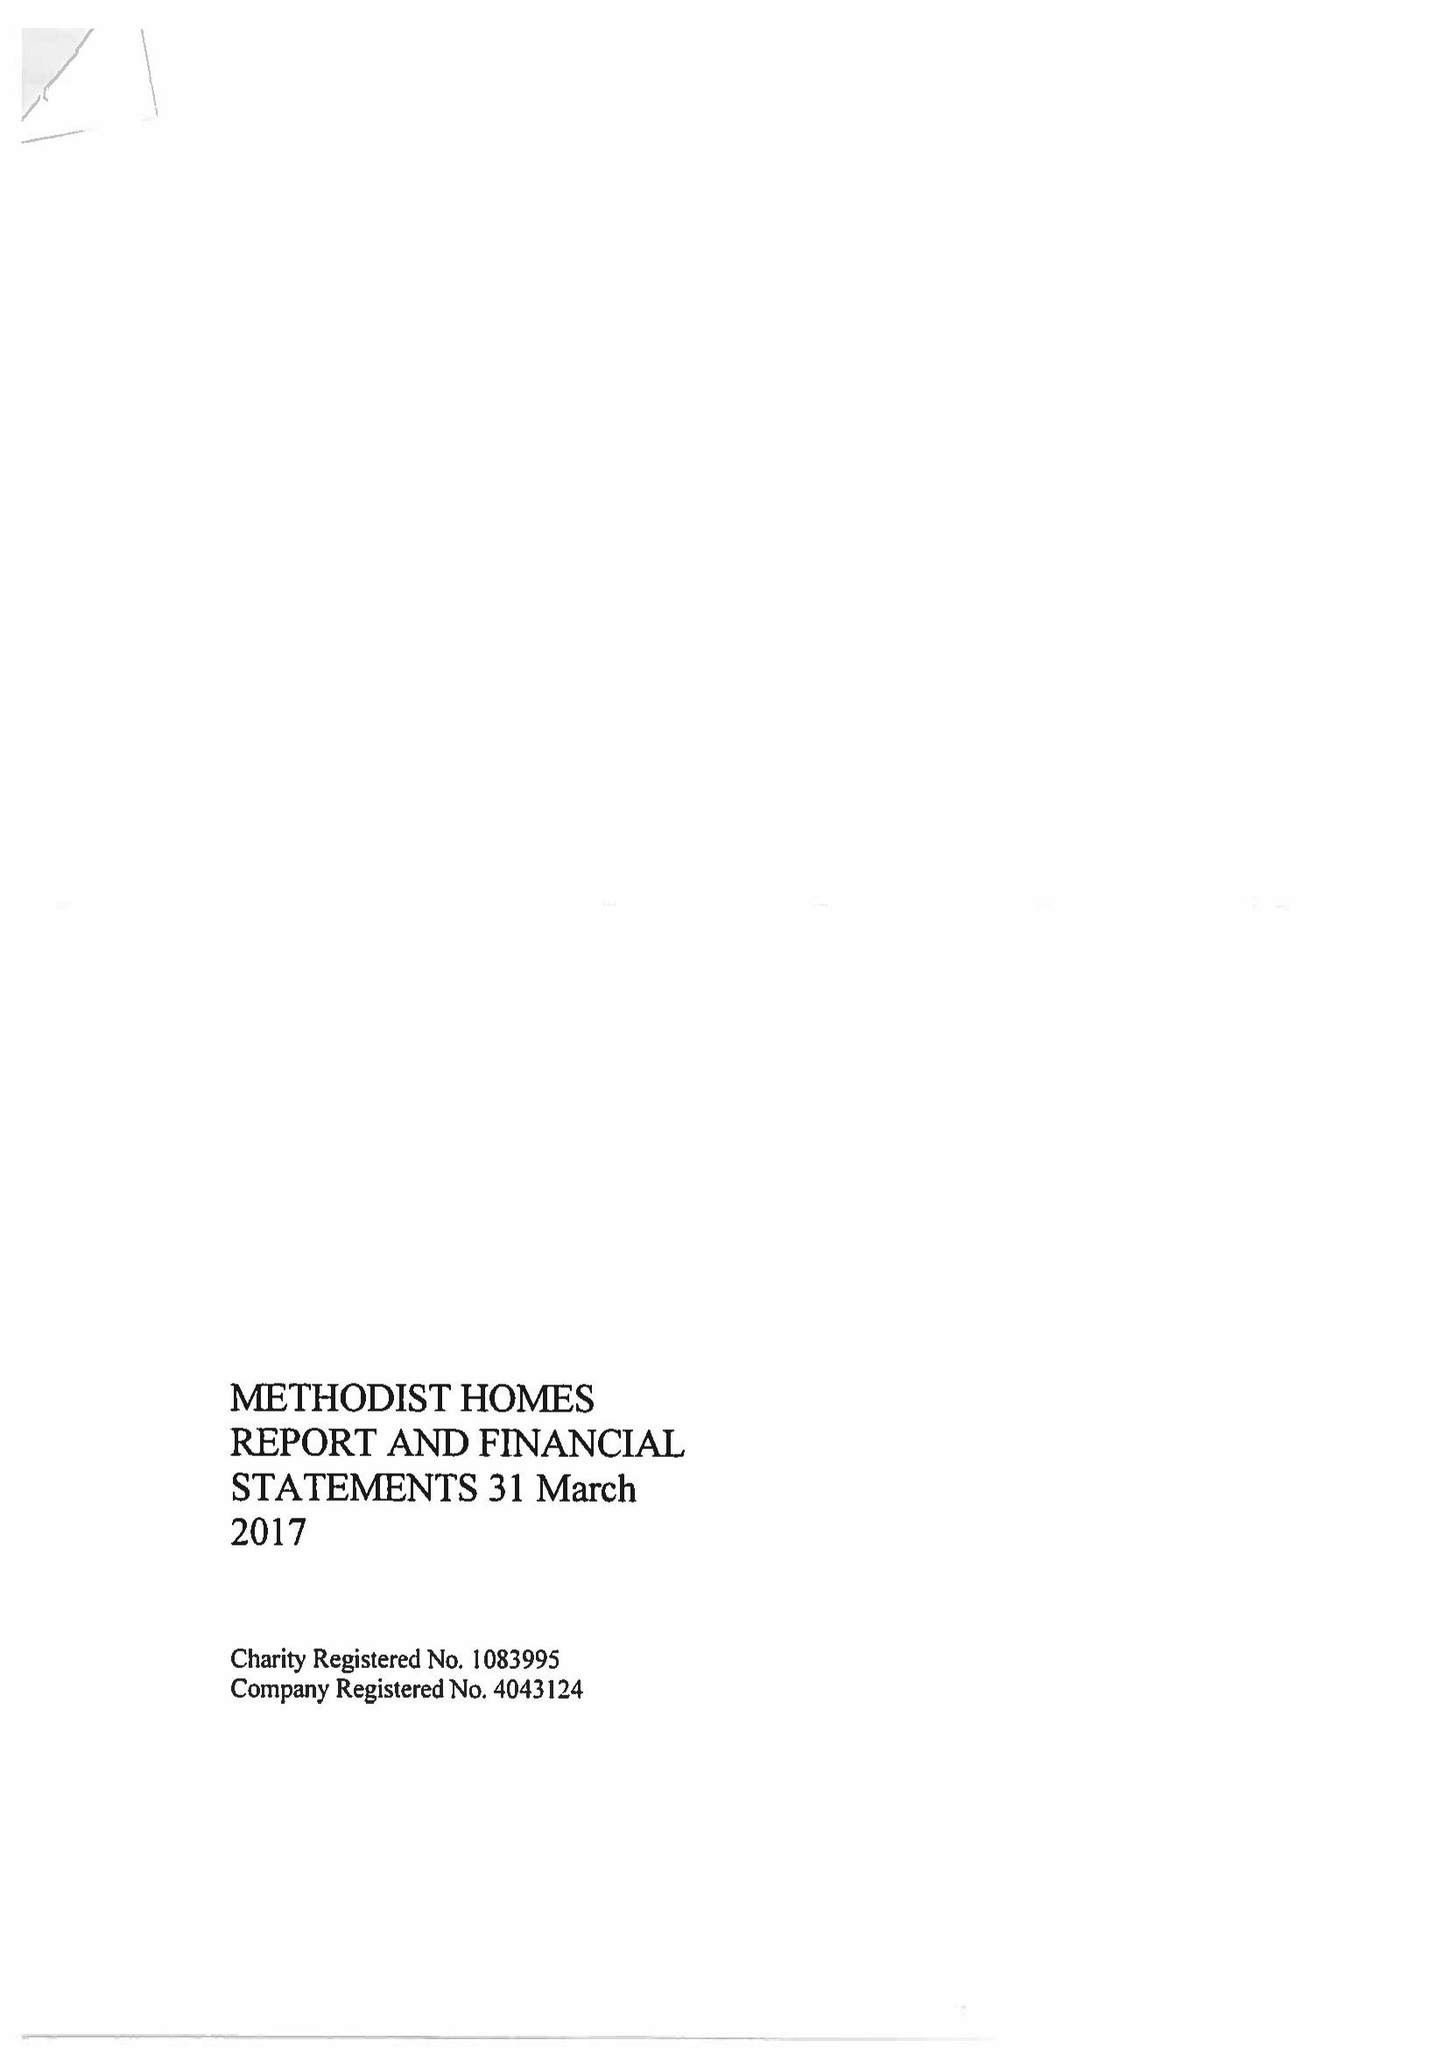What is the value for the income_annually_in_british_pounds?
Answer the question using a single word or phrase. 207089000.00 